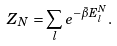<formula> <loc_0><loc_0><loc_500><loc_500>Z _ { N } = \sum _ { l } e ^ { - \bar { \beta } E _ { l } ^ { N } } .</formula> 